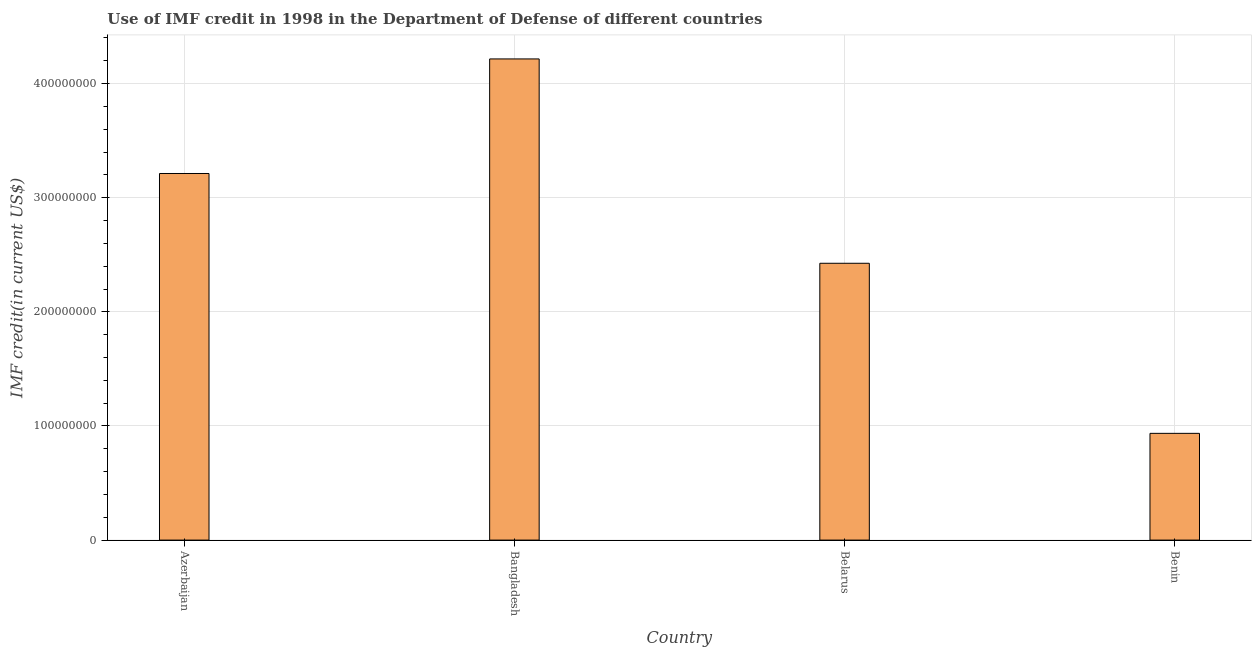Does the graph contain any zero values?
Your response must be concise. No. What is the title of the graph?
Keep it short and to the point. Use of IMF credit in 1998 in the Department of Defense of different countries. What is the label or title of the X-axis?
Make the answer very short. Country. What is the label or title of the Y-axis?
Make the answer very short. IMF credit(in current US$). What is the use of imf credit in dod in Belarus?
Provide a succinct answer. 2.43e+08. Across all countries, what is the maximum use of imf credit in dod?
Your answer should be very brief. 4.22e+08. Across all countries, what is the minimum use of imf credit in dod?
Keep it short and to the point. 9.35e+07. In which country was the use of imf credit in dod minimum?
Your response must be concise. Benin. What is the sum of the use of imf credit in dod?
Ensure brevity in your answer.  1.08e+09. What is the difference between the use of imf credit in dod in Bangladesh and Benin?
Ensure brevity in your answer.  3.28e+08. What is the average use of imf credit in dod per country?
Your answer should be compact. 2.70e+08. What is the median use of imf credit in dod?
Keep it short and to the point. 2.82e+08. In how many countries, is the use of imf credit in dod greater than 320000000 US$?
Keep it short and to the point. 2. What is the ratio of the use of imf credit in dod in Azerbaijan to that in Bangladesh?
Make the answer very short. 0.76. Is the use of imf credit in dod in Belarus less than that in Benin?
Your answer should be very brief. No. What is the difference between the highest and the second highest use of imf credit in dod?
Keep it short and to the point. 1.00e+08. Is the sum of the use of imf credit in dod in Bangladesh and Benin greater than the maximum use of imf credit in dod across all countries?
Give a very brief answer. Yes. What is the difference between the highest and the lowest use of imf credit in dod?
Provide a short and direct response. 3.28e+08. How many bars are there?
Offer a terse response. 4. Are all the bars in the graph horizontal?
Provide a short and direct response. No. How many countries are there in the graph?
Ensure brevity in your answer.  4. What is the IMF credit(in current US$) in Azerbaijan?
Your answer should be very brief. 3.21e+08. What is the IMF credit(in current US$) of Bangladesh?
Your answer should be compact. 4.22e+08. What is the IMF credit(in current US$) of Belarus?
Give a very brief answer. 2.43e+08. What is the IMF credit(in current US$) in Benin?
Offer a very short reply. 9.35e+07. What is the difference between the IMF credit(in current US$) in Azerbaijan and Bangladesh?
Give a very brief answer. -1.00e+08. What is the difference between the IMF credit(in current US$) in Azerbaijan and Belarus?
Your answer should be very brief. 7.87e+07. What is the difference between the IMF credit(in current US$) in Azerbaijan and Benin?
Your response must be concise. 2.28e+08. What is the difference between the IMF credit(in current US$) in Bangladesh and Belarus?
Keep it short and to the point. 1.79e+08. What is the difference between the IMF credit(in current US$) in Bangladesh and Benin?
Your answer should be very brief. 3.28e+08. What is the difference between the IMF credit(in current US$) in Belarus and Benin?
Make the answer very short. 1.49e+08. What is the ratio of the IMF credit(in current US$) in Azerbaijan to that in Bangladesh?
Make the answer very short. 0.76. What is the ratio of the IMF credit(in current US$) in Azerbaijan to that in Belarus?
Your response must be concise. 1.32. What is the ratio of the IMF credit(in current US$) in Azerbaijan to that in Benin?
Give a very brief answer. 3.43. What is the ratio of the IMF credit(in current US$) in Bangladesh to that in Belarus?
Your response must be concise. 1.74. What is the ratio of the IMF credit(in current US$) in Bangladesh to that in Benin?
Keep it short and to the point. 4.51. What is the ratio of the IMF credit(in current US$) in Belarus to that in Benin?
Give a very brief answer. 2.59. 